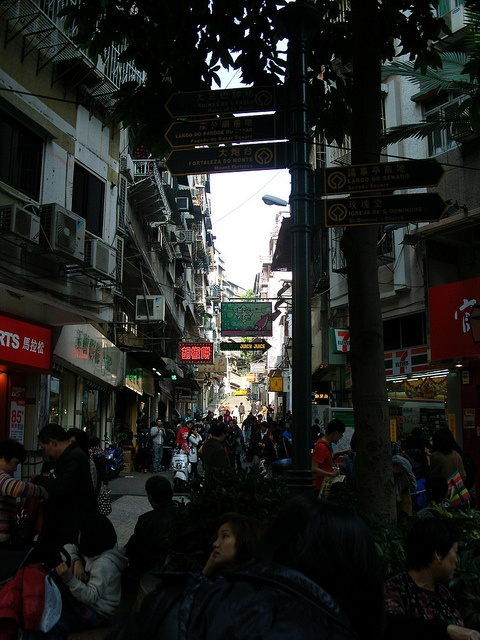Describe the objects in this image and their specific colors. I can see people in black, gray, purple, and maroon tones, people in black and maroon tones, people in black and gray tones, people in black and gray tones, and people in black and maroon tones in this image. 